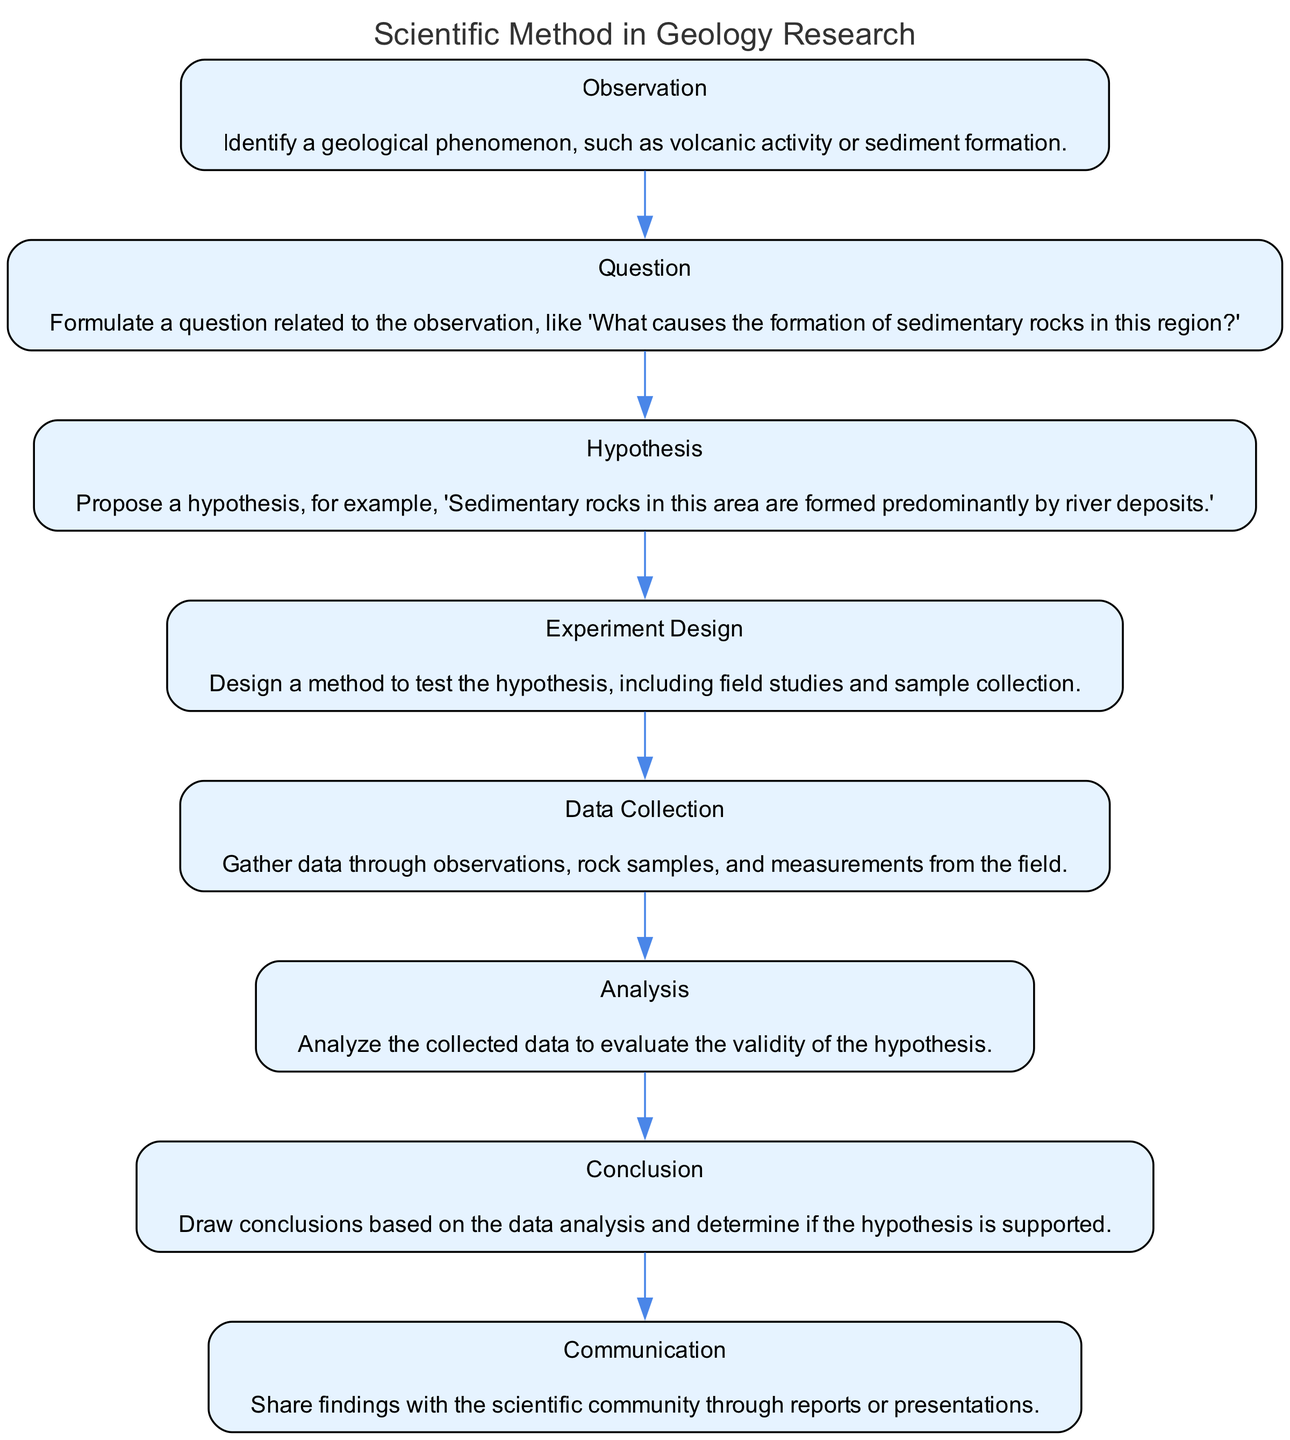What is the first step in the scientific method for geology research? The diagram indicates that the first step is "Observation." This can be inferred from the topmost node in the flow chart.
Answer: Observation How many steps are there in the scientific method according to the diagram? By counting the nodes in the diagram, there are a total of eight steps outlined in the flow chart.
Answer: Eight What is the hypothesis proposed in the scientific method according to the diagram? The diagram outlines the hypothesis as "Sedimentary rocks in this area are formed predominantly by river deposits." This information is located in the respective node labeled "Hypothesis."
Answer: Sedimentary rocks in this area are formed predominantly by river deposits What step follows 'Data Collection' in the scientific method? Following the 'Data Collection' step, the next step is 'Analysis,' as indicated by the connection between these two nodes in the flow.
Answer: Analysis Which step involves sharing findings with the scientific community? The last step of the process, as shown in the diagram, involves "Communication," where researchers share their findings.
Answer: Communication What question might one formulate after making an observation? After making an observation, the next logical step is to form a question. The example given in the flow chart is, "What causes the formation of sedimentary rocks in this region?"
Answer: What causes the formation of sedimentary rocks in this region? Why is 'Experiment Design' critical in the scientific method? 'Experiment Design' is critical because it outlines a method to test the hypothesis, ensuring that collected data will be valid and relevant. This step directly contributes to verifying or refuting the hypothesis.
Answer: It outlines a method to test the hypothesis Which step directly evaluates the validity of the hypothesis? The step that evaluates the validity of the hypothesis as shown in the diagram is 'Analysis.' This step involves scrutinizing the collected data to determine if it supports the proposed hypothesis.
Answer: Analysis 